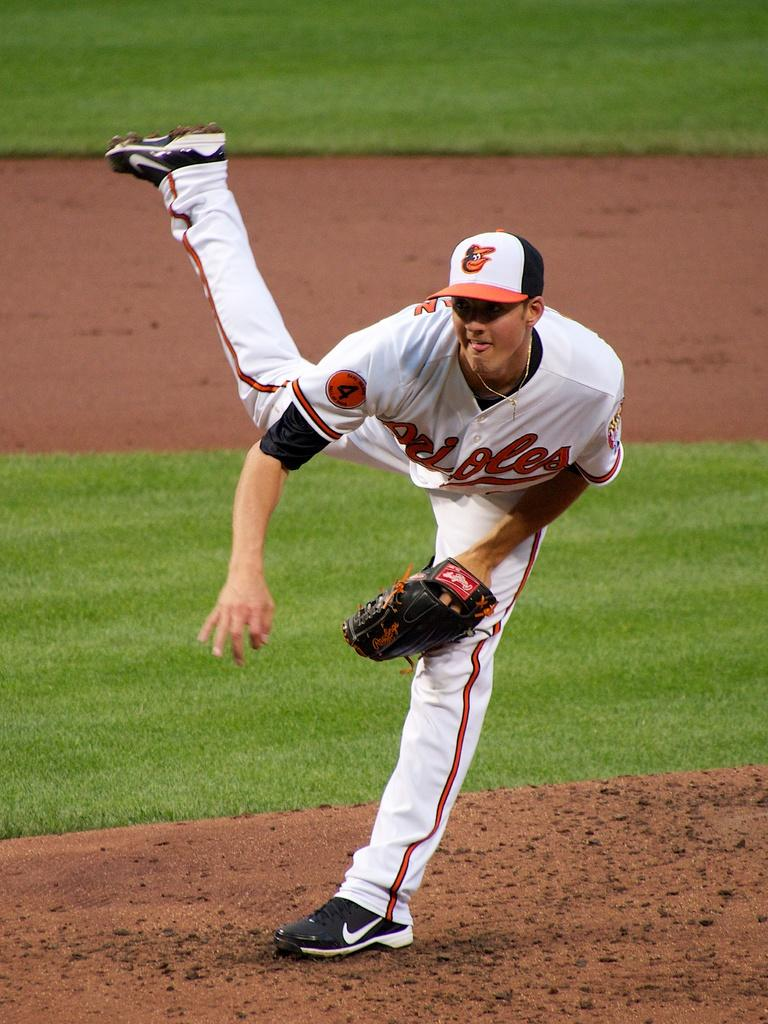<image>
Describe the image concisely. the number 4 player is pitching the ball 